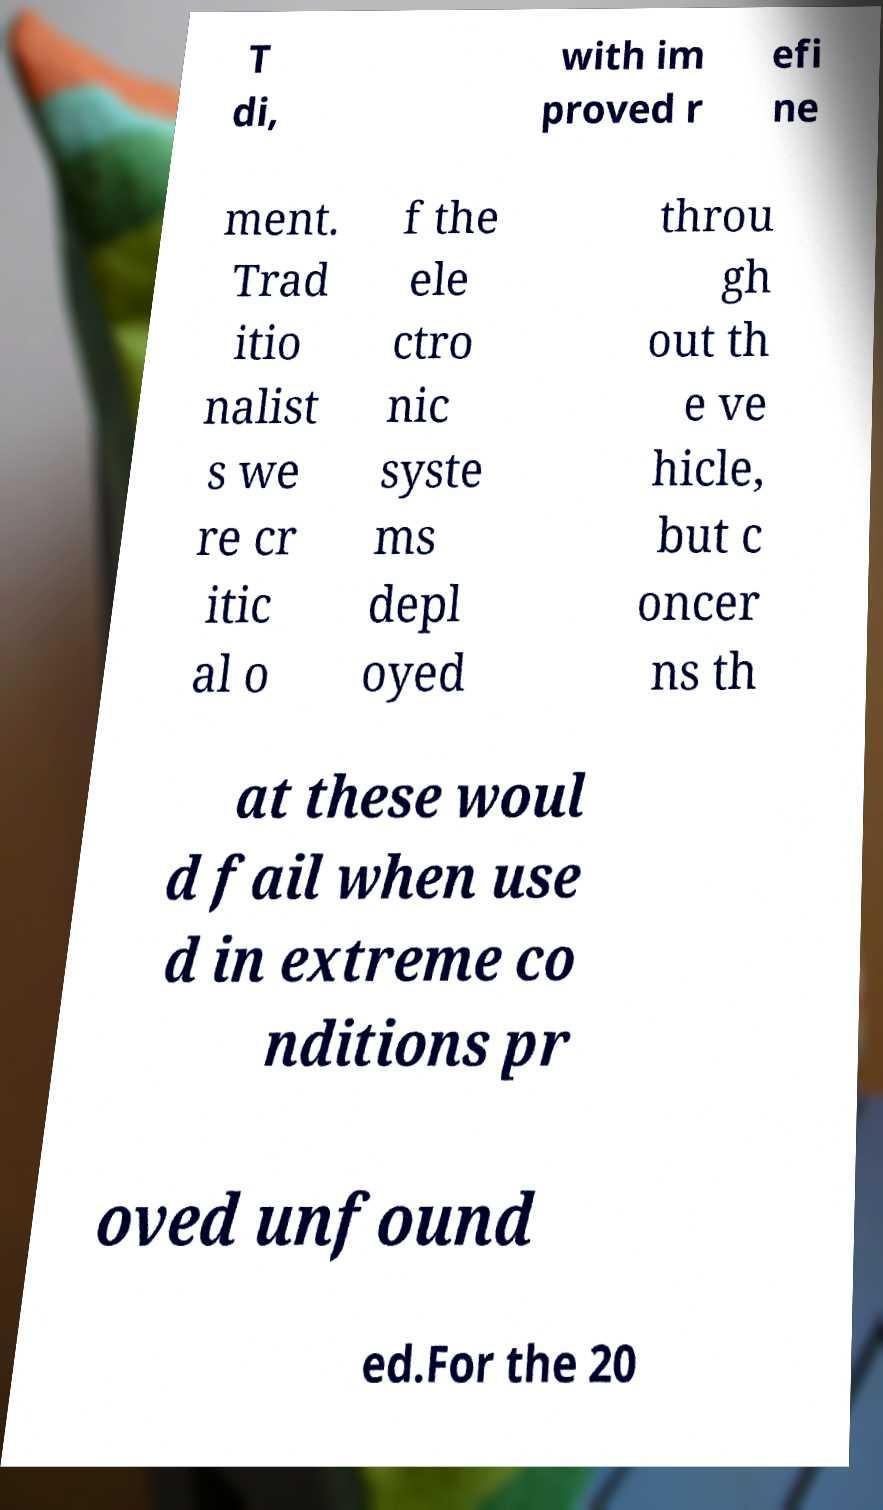Can you read and provide the text displayed in the image?This photo seems to have some interesting text. Can you extract and type it out for me? T di, with im proved r efi ne ment. Trad itio nalist s we re cr itic al o f the ele ctro nic syste ms depl oyed throu gh out th e ve hicle, but c oncer ns th at these woul d fail when use d in extreme co nditions pr oved unfound ed.For the 20 